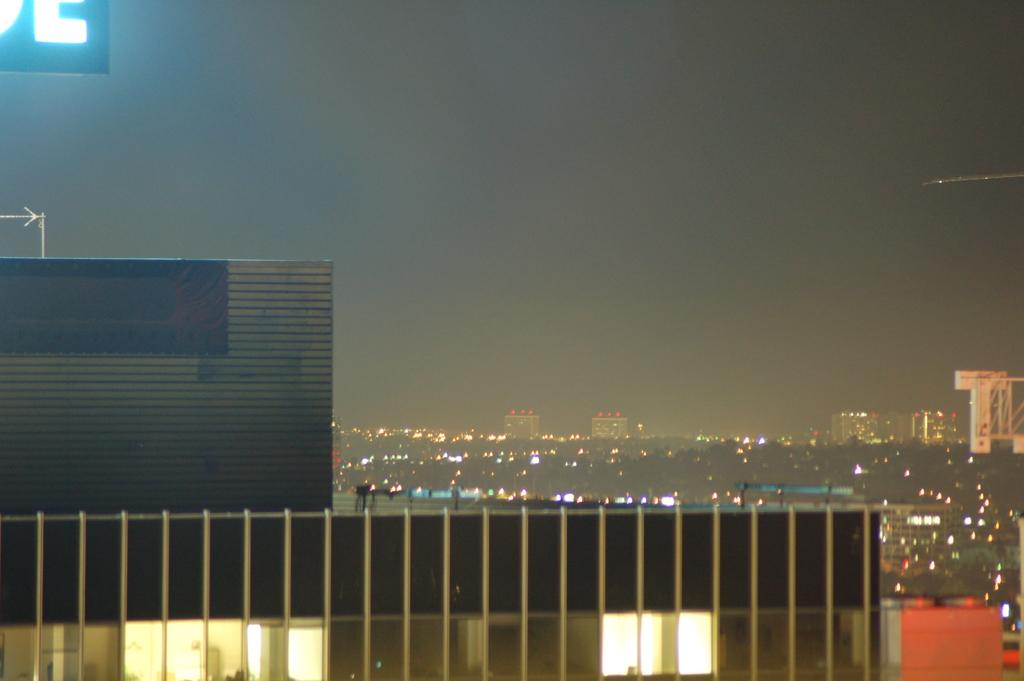What is the main subject of the image? There is a building in the image. Can you describe the surroundings of the main subject? There are other buildings in the background of the image. What else can be seen in the background? Lights are visible in the background. How would you describe the overall lighting in the image? The sky is dark in the image. What type of leather material is used to make the zipper on the bomb in the image? There is no bomb, zipper, or leather present in the image. 